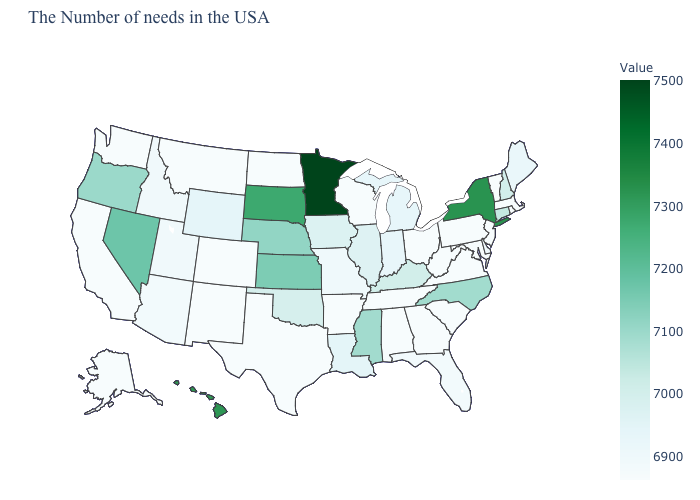Which states have the lowest value in the South?
Concise answer only. Maryland, Virginia, South Carolina, West Virginia, Georgia, Alabama, Tennessee, Arkansas, Texas. Which states hav the highest value in the South?
Answer briefly. Mississippi. Does the map have missing data?
Answer briefly. No. Which states have the lowest value in the USA?
Be succinct. Massachusetts, Rhode Island, Vermont, New Jersey, Maryland, Pennsylvania, Virginia, South Carolina, West Virginia, Ohio, Georgia, Alabama, Tennessee, Wisconsin, Arkansas, Texas, North Dakota, Colorado, New Mexico, Montana, California, Washington, Alaska. 